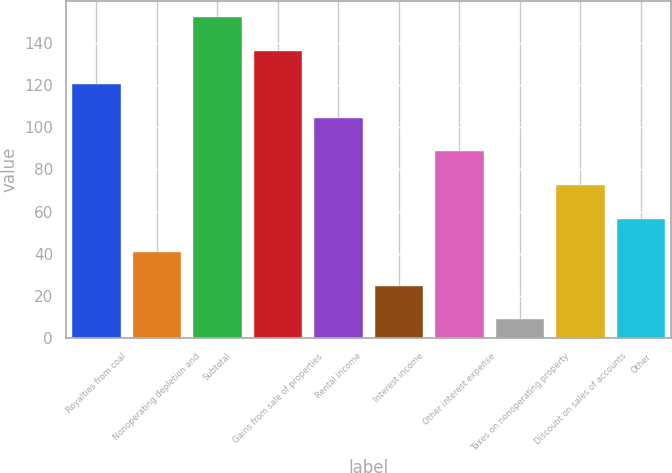Convert chart. <chart><loc_0><loc_0><loc_500><loc_500><bar_chart><fcel>Royalties from coal<fcel>Nonoperating depletion and<fcel>Subtotal<fcel>Gains from sale of properties<fcel>Rental income<fcel>Interest income<fcel>Other interest expense<fcel>Taxes on nonoperating property<fcel>Discount on sales of accounts<fcel>Other<nl><fcel>120.3<fcel>40.8<fcel>152.1<fcel>136.2<fcel>104.4<fcel>24.9<fcel>88.5<fcel>9<fcel>72.6<fcel>56.7<nl></chart> 